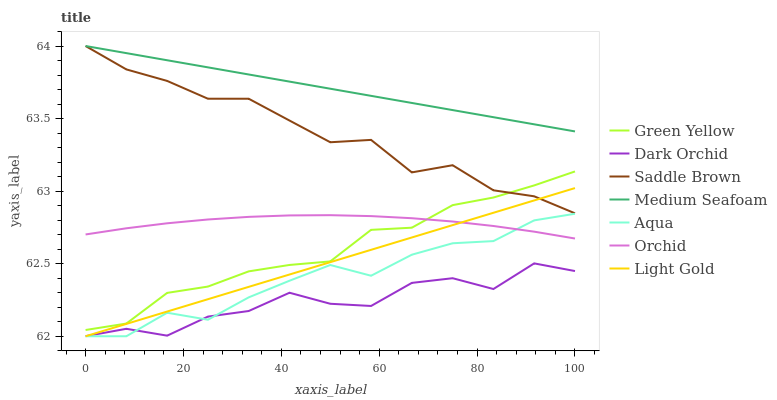Does Dark Orchid have the minimum area under the curve?
Answer yes or no. Yes. Does Medium Seafoam have the maximum area under the curve?
Answer yes or no. Yes. Does Medium Seafoam have the minimum area under the curve?
Answer yes or no. No. Does Dark Orchid have the maximum area under the curve?
Answer yes or no. No. Is Light Gold the smoothest?
Answer yes or no. Yes. Is Dark Orchid the roughest?
Answer yes or no. Yes. Is Medium Seafoam the smoothest?
Answer yes or no. No. Is Medium Seafoam the roughest?
Answer yes or no. No. Does Aqua have the lowest value?
Answer yes or no. Yes. Does Dark Orchid have the lowest value?
Answer yes or no. No. Does Saddle Brown have the highest value?
Answer yes or no. Yes. Does Dark Orchid have the highest value?
Answer yes or no. No. Is Aqua less than Medium Seafoam?
Answer yes or no. Yes. Is Green Yellow greater than Dark Orchid?
Answer yes or no. Yes. Does Light Gold intersect Dark Orchid?
Answer yes or no. Yes. Is Light Gold less than Dark Orchid?
Answer yes or no. No. Is Light Gold greater than Dark Orchid?
Answer yes or no. No. Does Aqua intersect Medium Seafoam?
Answer yes or no. No. 